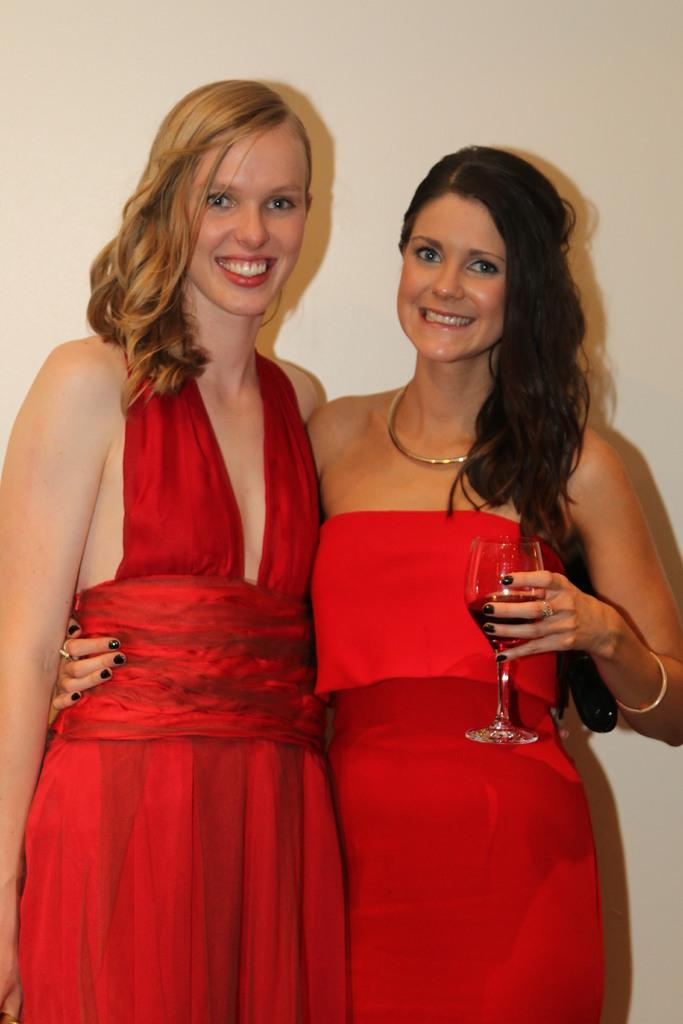How many women are in the image? There are two women in the image. What are the women wearing? Both women are dressed in red. What are the women doing in the image? The women are posing for a camera. Can you describe the woman holding an object in her hand? One of the women is holding a wine glass in her left hand. What type of brick is being used as a scarf by the women in the image? A: There is no brick or scarf present in the image; the women are dressed in red and one of them is holding a wine glass. 